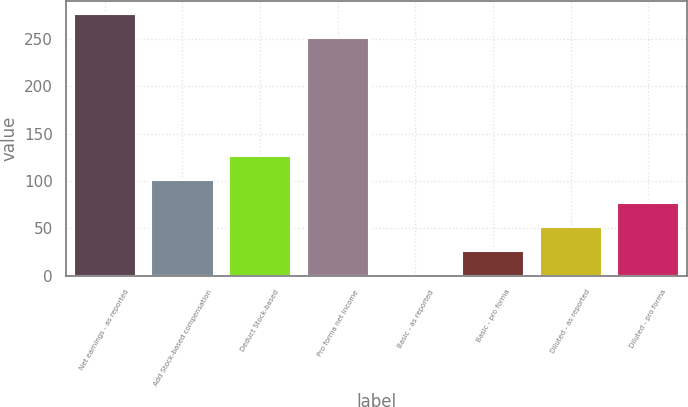<chart> <loc_0><loc_0><loc_500><loc_500><bar_chart><fcel>Net earnings - as reported<fcel>Add Stock-based compensation<fcel>Deduct Stock-based<fcel>Pro forma net income<fcel>Basic - as reported<fcel>Basic - pro forma<fcel>Diluted - as reported<fcel>Diluted - pro forma<nl><fcel>276<fcel>101.3<fcel>126.3<fcel>251<fcel>1.3<fcel>26.3<fcel>51.3<fcel>76.3<nl></chart> 